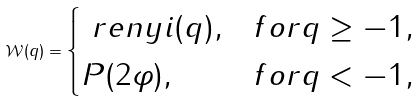<formula> <loc_0><loc_0><loc_500><loc_500>\mathcal { W } ( q ) = \begin{cases} \ r e n y i ( q ) , & f o r q \geq - 1 , \\ P ( 2 \varphi ) , & f o r q < - 1 , \end{cases}</formula> 